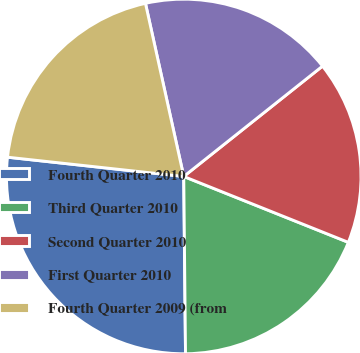<chart> <loc_0><loc_0><loc_500><loc_500><pie_chart><fcel>Fourth Quarter 2010<fcel>Third Quarter 2010<fcel>Second Quarter 2010<fcel>First Quarter 2010<fcel>Fourth Quarter 2009 (from<nl><fcel>26.89%<fcel>18.78%<fcel>16.75%<fcel>17.77%<fcel>19.8%<nl></chart> 